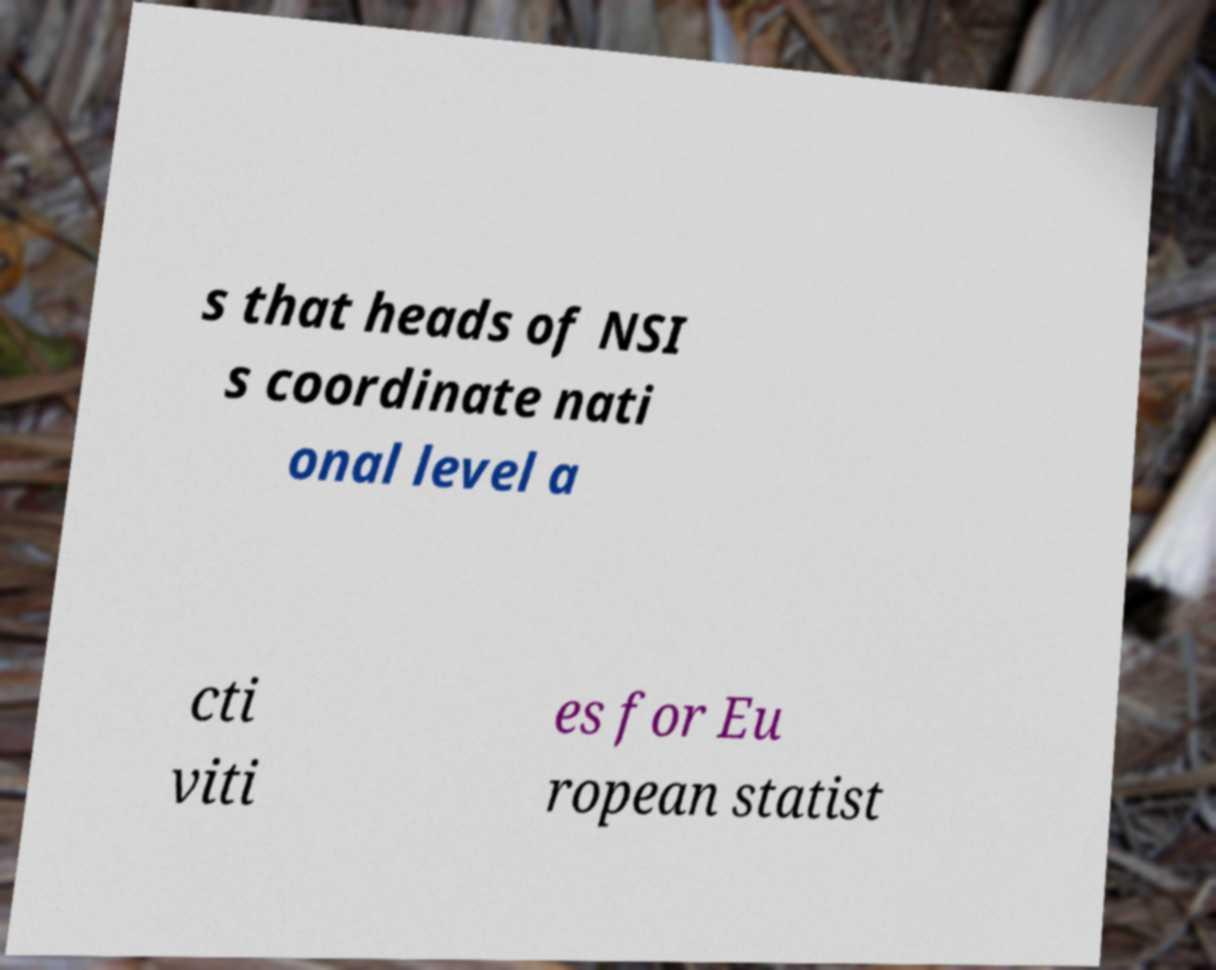There's text embedded in this image that I need extracted. Can you transcribe it verbatim? s that heads of NSI s coordinate nati onal level a cti viti es for Eu ropean statist 